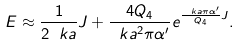Convert formula to latex. <formula><loc_0><loc_0><loc_500><loc_500>E \approx \frac { 1 } { 2 \ k a } J + \frac { 4 Q _ { 4 } } { \ k a ^ { 2 } \pi \alpha ^ { \prime } } e ^ { \frac { \ k a \pi \alpha ^ { \prime } } { Q _ { 4 } } J } .</formula> 